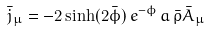Convert formula to latex. <formula><loc_0><loc_0><loc_500><loc_500>\bar { j } _ { \mu } = - 2 \sinh ( 2 \bar { \phi } ) \, e ^ { - \phi } \, a \, \bar { \rho } \bar { A } _ { \mu }</formula> 